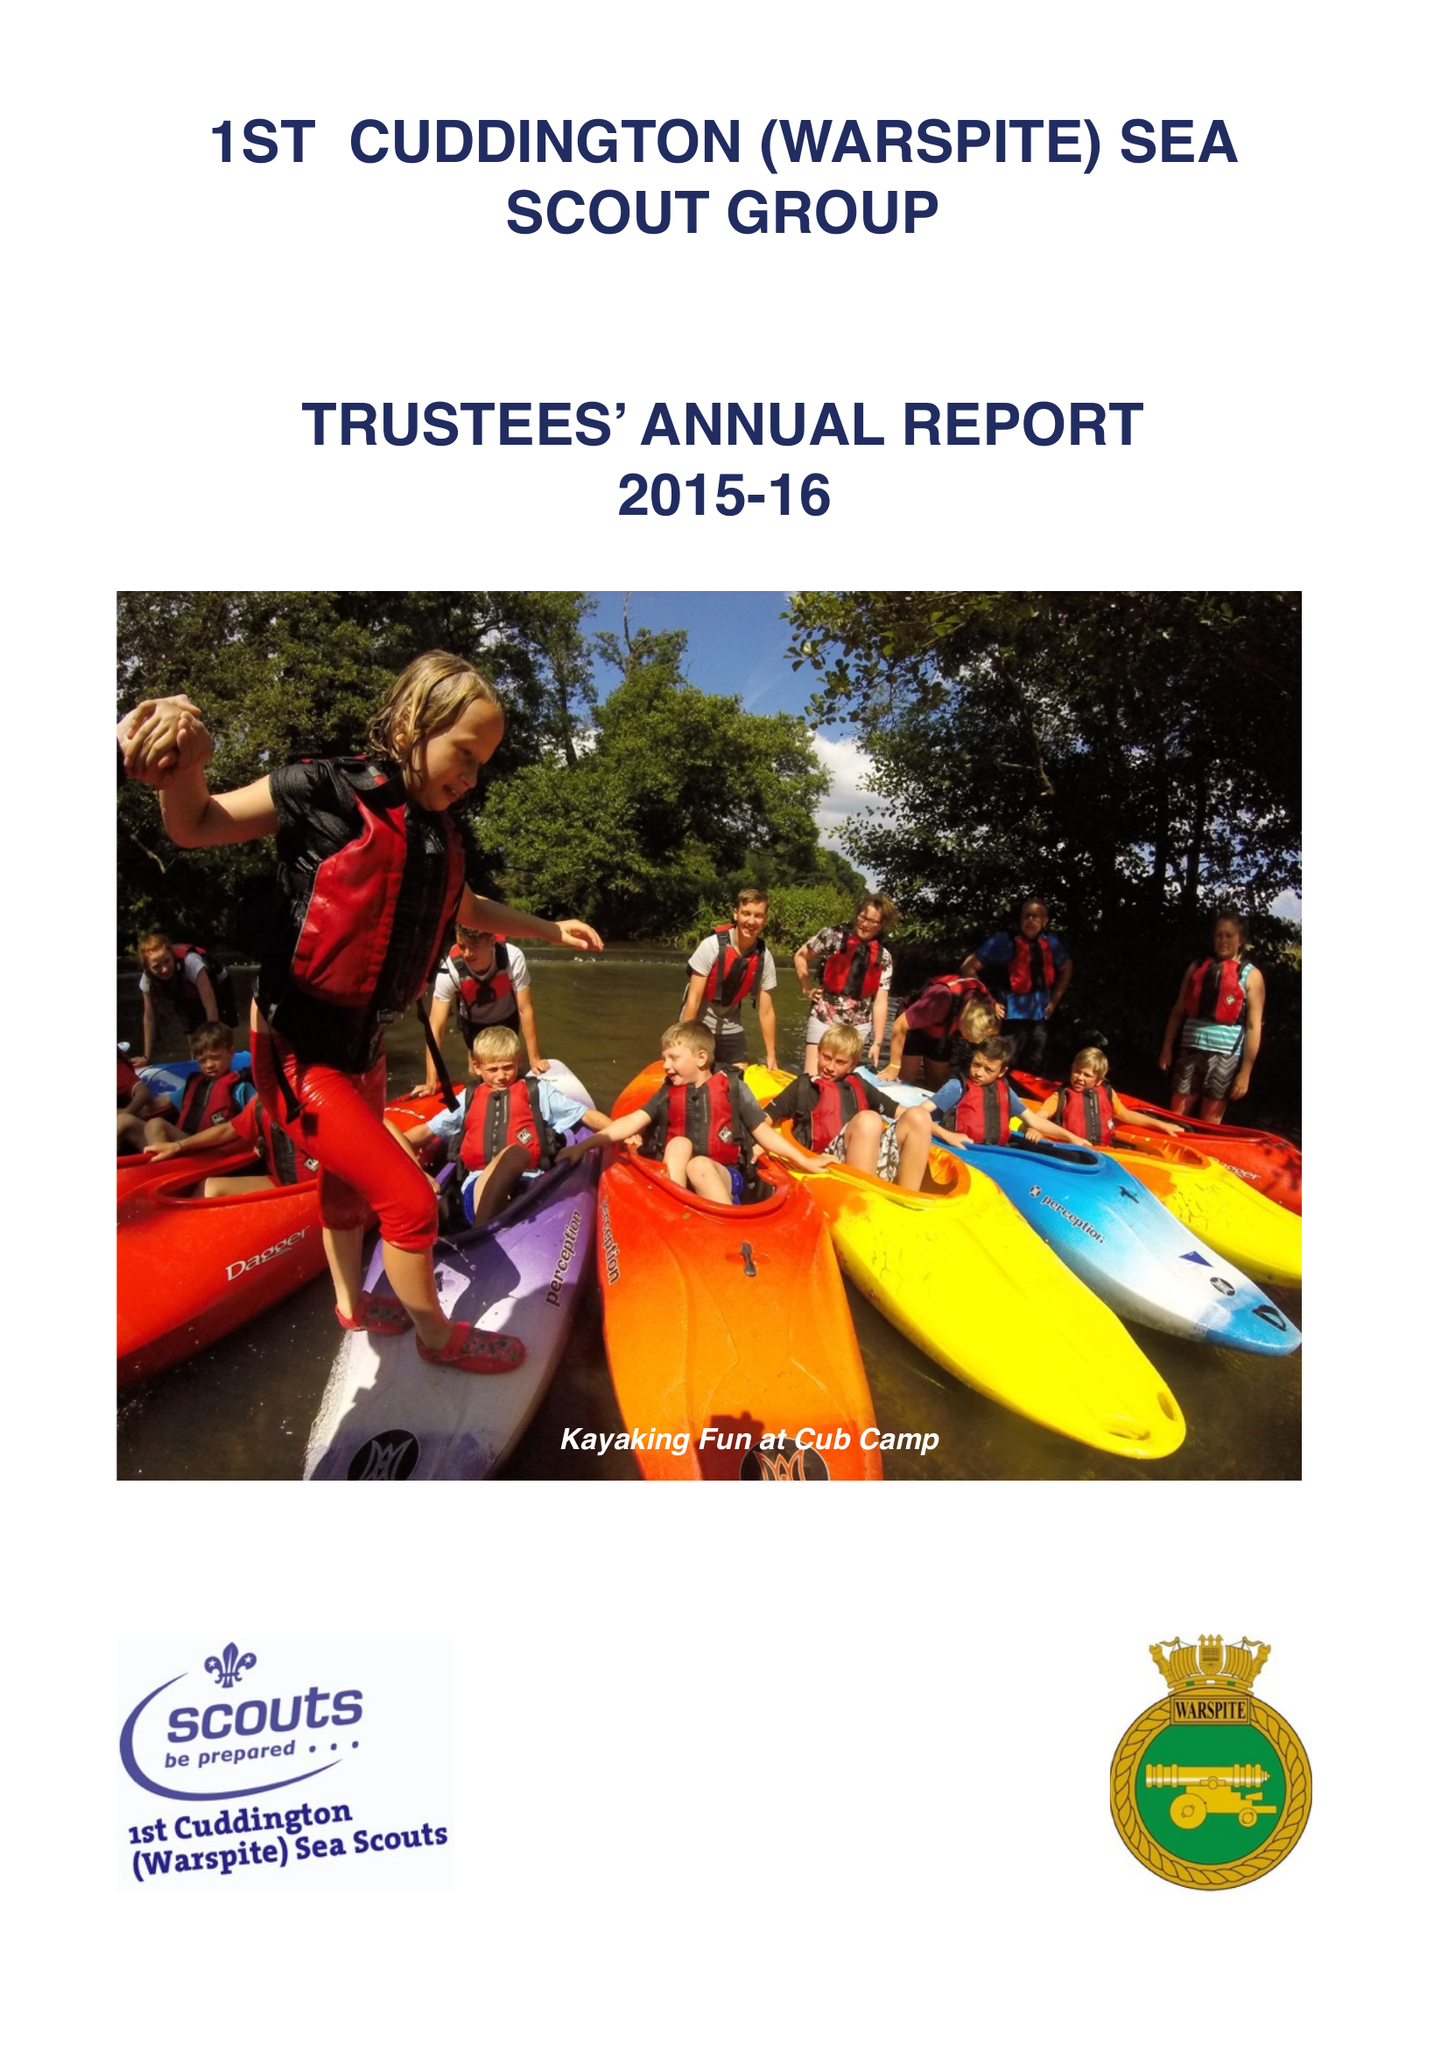What is the value for the address__street_line?
Answer the question using a single word or phrase. 87 CASTLE AVENUE 